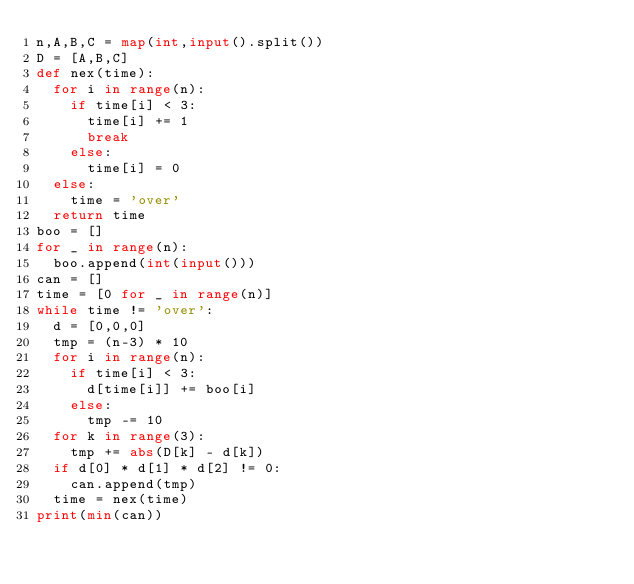<code> <loc_0><loc_0><loc_500><loc_500><_Python_>n,A,B,C = map(int,input().split())
D = [A,B,C]
def nex(time):
  for i in range(n):
    if time[i] < 3:
      time[i] += 1
      break
    else:
      time[i] = 0
  else:
    time = 'over'
  return time
boo = []
for _ in range(n):
  boo.append(int(input()))
can = []
time = [0 for _ in range(n)]
while time != 'over':
  d = [0,0,0]
  tmp = (n-3) * 10
  for i in range(n):
    if time[i] < 3:
      d[time[i]] += boo[i]
    else:
      tmp -= 10
  for k in range(3):
    tmp += abs(D[k] - d[k])
  if d[0] * d[1] * d[2] != 0:
    can.append(tmp)
  time = nex(time)
print(min(can))</code> 